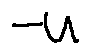Convert formula to latex. <formula><loc_0><loc_0><loc_500><loc_500>- u</formula> 